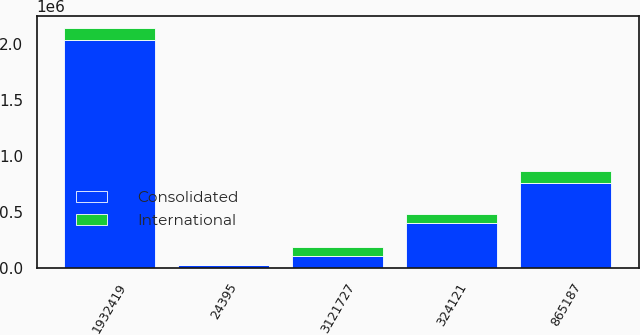Convert chart. <chart><loc_0><loc_0><loc_500><loc_500><stacked_bar_chart><ecel><fcel>24395<fcel>3121727<fcel>1932419<fcel>324121<fcel>865187<nl><fcel>International<fcel>1858<fcel>82850<fcel>107482<fcel>78517<fcel>103149<nl><fcel>Consolidated<fcel>26253<fcel>103149<fcel>2.0399e+06<fcel>402638<fcel>762038<nl></chart> 